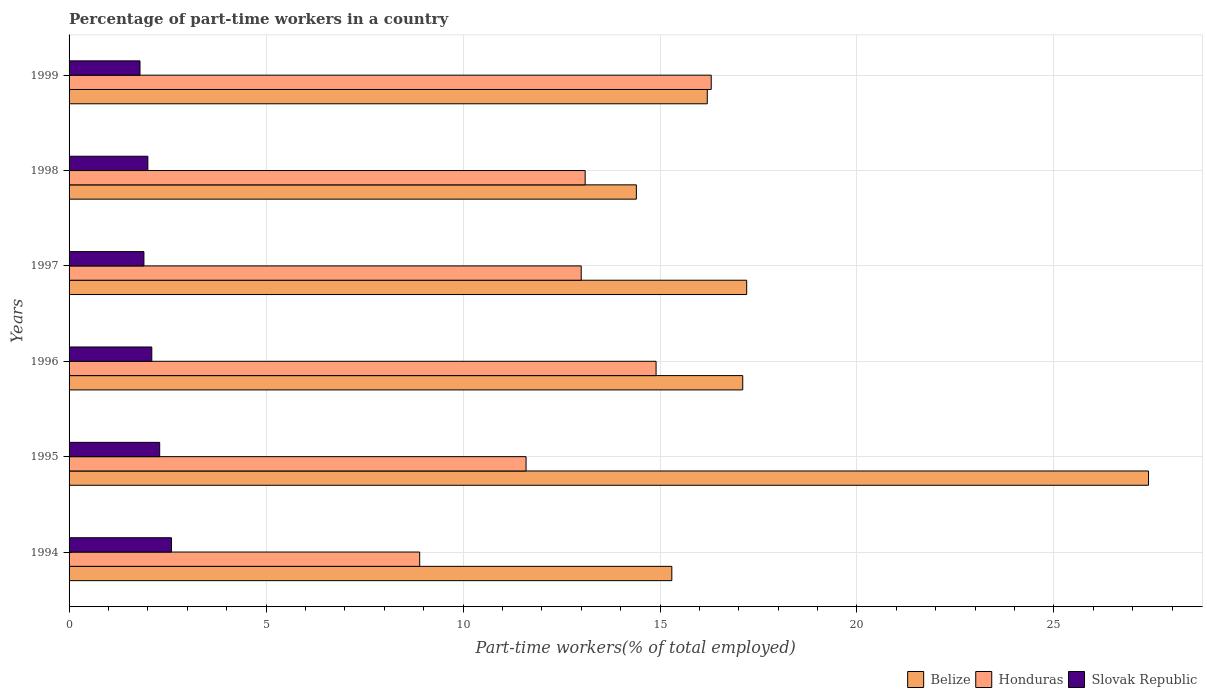Are the number of bars per tick equal to the number of legend labels?
Ensure brevity in your answer.  Yes. Are the number of bars on each tick of the Y-axis equal?
Make the answer very short. Yes. How many bars are there on the 4th tick from the bottom?
Make the answer very short. 3. What is the percentage of part-time workers in Slovak Republic in 1994?
Offer a terse response. 2.6. Across all years, what is the maximum percentage of part-time workers in Slovak Republic?
Ensure brevity in your answer.  2.6. Across all years, what is the minimum percentage of part-time workers in Belize?
Your answer should be compact. 14.4. What is the total percentage of part-time workers in Honduras in the graph?
Provide a succinct answer. 77.8. What is the difference between the percentage of part-time workers in Honduras in 1994 and that in 1997?
Your answer should be compact. -4.1. What is the difference between the percentage of part-time workers in Honduras in 1994 and the percentage of part-time workers in Slovak Republic in 1995?
Provide a short and direct response. 6.6. What is the average percentage of part-time workers in Slovak Republic per year?
Give a very brief answer. 2.12. In the year 1999, what is the difference between the percentage of part-time workers in Honduras and percentage of part-time workers in Belize?
Offer a terse response. 0.1. What is the ratio of the percentage of part-time workers in Honduras in 1996 to that in 1999?
Keep it short and to the point. 0.91. Is the difference between the percentage of part-time workers in Honduras in 1994 and 1997 greater than the difference between the percentage of part-time workers in Belize in 1994 and 1997?
Offer a very short reply. No. What is the difference between the highest and the second highest percentage of part-time workers in Belize?
Keep it short and to the point. 10.2. What is the difference between the highest and the lowest percentage of part-time workers in Slovak Republic?
Ensure brevity in your answer.  0.8. In how many years, is the percentage of part-time workers in Honduras greater than the average percentage of part-time workers in Honduras taken over all years?
Ensure brevity in your answer.  4. Is the sum of the percentage of part-time workers in Slovak Republic in 1995 and 1999 greater than the maximum percentage of part-time workers in Honduras across all years?
Offer a terse response. No. What does the 1st bar from the top in 1996 represents?
Offer a very short reply. Slovak Republic. What does the 1st bar from the bottom in 1994 represents?
Provide a short and direct response. Belize. Is it the case that in every year, the sum of the percentage of part-time workers in Belize and percentage of part-time workers in Honduras is greater than the percentage of part-time workers in Slovak Republic?
Provide a succinct answer. Yes. How many bars are there?
Your answer should be compact. 18. Are all the bars in the graph horizontal?
Ensure brevity in your answer.  Yes. Does the graph contain any zero values?
Ensure brevity in your answer.  No. Does the graph contain grids?
Your answer should be very brief. Yes. What is the title of the graph?
Provide a succinct answer. Percentage of part-time workers in a country. What is the label or title of the X-axis?
Make the answer very short. Part-time workers(% of total employed). What is the label or title of the Y-axis?
Keep it short and to the point. Years. What is the Part-time workers(% of total employed) of Belize in 1994?
Offer a very short reply. 15.3. What is the Part-time workers(% of total employed) in Honduras in 1994?
Keep it short and to the point. 8.9. What is the Part-time workers(% of total employed) in Slovak Republic in 1994?
Provide a short and direct response. 2.6. What is the Part-time workers(% of total employed) in Belize in 1995?
Give a very brief answer. 27.4. What is the Part-time workers(% of total employed) of Honduras in 1995?
Your response must be concise. 11.6. What is the Part-time workers(% of total employed) in Slovak Republic in 1995?
Provide a short and direct response. 2.3. What is the Part-time workers(% of total employed) of Belize in 1996?
Offer a very short reply. 17.1. What is the Part-time workers(% of total employed) of Honduras in 1996?
Give a very brief answer. 14.9. What is the Part-time workers(% of total employed) in Slovak Republic in 1996?
Offer a very short reply. 2.1. What is the Part-time workers(% of total employed) in Belize in 1997?
Your answer should be compact. 17.2. What is the Part-time workers(% of total employed) in Honduras in 1997?
Provide a short and direct response. 13. What is the Part-time workers(% of total employed) of Slovak Republic in 1997?
Provide a short and direct response. 1.9. What is the Part-time workers(% of total employed) in Belize in 1998?
Give a very brief answer. 14.4. What is the Part-time workers(% of total employed) of Honduras in 1998?
Your answer should be very brief. 13.1. What is the Part-time workers(% of total employed) of Slovak Republic in 1998?
Make the answer very short. 2. What is the Part-time workers(% of total employed) in Belize in 1999?
Give a very brief answer. 16.2. What is the Part-time workers(% of total employed) in Honduras in 1999?
Make the answer very short. 16.3. What is the Part-time workers(% of total employed) of Slovak Republic in 1999?
Provide a succinct answer. 1.8. Across all years, what is the maximum Part-time workers(% of total employed) in Belize?
Your answer should be compact. 27.4. Across all years, what is the maximum Part-time workers(% of total employed) of Honduras?
Keep it short and to the point. 16.3. Across all years, what is the maximum Part-time workers(% of total employed) in Slovak Republic?
Keep it short and to the point. 2.6. Across all years, what is the minimum Part-time workers(% of total employed) in Belize?
Your answer should be very brief. 14.4. Across all years, what is the minimum Part-time workers(% of total employed) of Honduras?
Your answer should be very brief. 8.9. Across all years, what is the minimum Part-time workers(% of total employed) in Slovak Republic?
Offer a terse response. 1.8. What is the total Part-time workers(% of total employed) in Belize in the graph?
Provide a succinct answer. 107.6. What is the total Part-time workers(% of total employed) of Honduras in the graph?
Provide a succinct answer. 77.8. What is the total Part-time workers(% of total employed) of Slovak Republic in the graph?
Your answer should be compact. 12.7. What is the difference between the Part-time workers(% of total employed) of Belize in 1994 and that in 1995?
Offer a terse response. -12.1. What is the difference between the Part-time workers(% of total employed) in Honduras in 1994 and that in 1995?
Offer a very short reply. -2.7. What is the difference between the Part-time workers(% of total employed) of Slovak Republic in 1994 and that in 1995?
Your response must be concise. 0.3. What is the difference between the Part-time workers(% of total employed) in Belize in 1994 and that in 1996?
Your answer should be very brief. -1.8. What is the difference between the Part-time workers(% of total employed) in Honduras in 1994 and that in 1996?
Your answer should be compact. -6. What is the difference between the Part-time workers(% of total employed) in Belize in 1994 and that in 1997?
Ensure brevity in your answer.  -1.9. What is the difference between the Part-time workers(% of total employed) in Honduras in 1994 and that in 1997?
Make the answer very short. -4.1. What is the difference between the Part-time workers(% of total employed) in Slovak Republic in 1994 and that in 1997?
Ensure brevity in your answer.  0.7. What is the difference between the Part-time workers(% of total employed) of Honduras in 1994 and that in 1998?
Ensure brevity in your answer.  -4.2. What is the difference between the Part-time workers(% of total employed) in Slovak Republic in 1994 and that in 1998?
Keep it short and to the point. 0.6. What is the difference between the Part-time workers(% of total employed) in Belize in 1994 and that in 1999?
Provide a succinct answer. -0.9. What is the difference between the Part-time workers(% of total employed) of Belize in 1995 and that in 1996?
Offer a terse response. 10.3. What is the difference between the Part-time workers(% of total employed) in Slovak Republic in 1995 and that in 1997?
Ensure brevity in your answer.  0.4. What is the difference between the Part-time workers(% of total employed) of Belize in 1995 and that in 1998?
Your response must be concise. 13. What is the difference between the Part-time workers(% of total employed) in Slovak Republic in 1995 and that in 1998?
Offer a terse response. 0.3. What is the difference between the Part-time workers(% of total employed) of Slovak Republic in 1995 and that in 1999?
Offer a terse response. 0.5. What is the difference between the Part-time workers(% of total employed) in Belize in 1996 and that in 1997?
Provide a short and direct response. -0.1. What is the difference between the Part-time workers(% of total employed) in Belize in 1996 and that in 1998?
Ensure brevity in your answer.  2.7. What is the difference between the Part-time workers(% of total employed) of Slovak Republic in 1996 and that in 1998?
Your answer should be compact. 0.1. What is the difference between the Part-time workers(% of total employed) in Honduras in 1996 and that in 1999?
Ensure brevity in your answer.  -1.4. What is the difference between the Part-time workers(% of total employed) of Slovak Republic in 1996 and that in 1999?
Your answer should be very brief. 0.3. What is the difference between the Part-time workers(% of total employed) of Belize in 1997 and that in 1998?
Your answer should be compact. 2.8. What is the difference between the Part-time workers(% of total employed) of Honduras in 1997 and that in 1998?
Give a very brief answer. -0.1. What is the difference between the Part-time workers(% of total employed) of Slovak Republic in 1997 and that in 1998?
Offer a terse response. -0.1. What is the difference between the Part-time workers(% of total employed) of Belize in 1997 and that in 1999?
Your response must be concise. 1. What is the difference between the Part-time workers(% of total employed) of Slovak Republic in 1997 and that in 1999?
Offer a very short reply. 0.1. What is the difference between the Part-time workers(% of total employed) of Belize in 1998 and that in 1999?
Offer a terse response. -1.8. What is the difference between the Part-time workers(% of total employed) of Honduras in 1998 and that in 1999?
Give a very brief answer. -3.2. What is the difference between the Part-time workers(% of total employed) of Honduras in 1994 and the Part-time workers(% of total employed) of Slovak Republic in 1996?
Ensure brevity in your answer.  6.8. What is the difference between the Part-time workers(% of total employed) in Belize in 1994 and the Part-time workers(% of total employed) in Slovak Republic in 1997?
Provide a short and direct response. 13.4. What is the difference between the Part-time workers(% of total employed) in Belize in 1994 and the Part-time workers(% of total employed) in Slovak Republic in 1998?
Keep it short and to the point. 13.3. What is the difference between the Part-time workers(% of total employed) in Belize in 1994 and the Part-time workers(% of total employed) in Honduras in 1999?
Your answer should be compact. -1. What is the difference between the Part-time workers(% of total employed) of Belize in 1994 and the Part-time workers(% of total employed) of Slovak Republic in 1999?
Ensure brevity in your answer.  13.5. What is the difference between the Part-time workers(% of total employed) in Honduras in 1994 and the Part-time workers(% of total employed) in Slovak Republic in 1999?
Make the answer very short. 7.1. What is the difference between the Part-time workers(% of total employed) of Belize in 1995 and the Part-time workers(% of total employed) of Honduras in 1996?
Offer a very short reply. 12.5. What is the difference between the Part-time workers(% of total employed) of Belize in 1995 and the Part-time workers(% of total employed) of Slovak Republic in 1996?
Offer a very short reply. 25.3. What is the difference between the Part-time workers(% of total employed) in Honduras in 1995 and the Part-time workers(% of total employed) in Slovak Republic in 1996?
Your answer should be compact. 9.5. What is the difference between the Part-time workers(% of total employed) in Belize in 1995 and the Part-time workers(% of total employed) in Slovak Republic in 1997?
Provide a short and direct response. 25.5. What is the difference between the Part-time workers(% of total employed) of Honduras in 1995 and the Part-time workers(% of total employed) of Slovak Republic in 1997?
Offer a terse response. 9.7. What is the difference between the Part-time workers(% of total employed) in Belize in 1995 and the Part-time workers(% of total employed) in Honduras in 1998?
Offer a very short reply. 14.3. What is the difference between the Part-time workers(% of total employed) of Belize in 1995 and the Part-time workers(% of total employed) of Slovak Republic in 1998?
Your response must be concise. 25.4. What is the difference between the Part-time workers(% of total employed) of Honduras in 1995 and the Part-time workers(% of total employed) of Slovak Republic in 1998?
Ensure brevity in your answer.  9.6. What is the difference between the Part-time workers(% of total employed) in Belize in 1995 and the Part-time workers(% of total employed) in Honduras in 1999?
Ensure brevity in your answer.  11.1. What is the difference between the Part-time workers(% of total employed) of Belize in 1995 and the Part-time workers(% of total employed) of Slovak Republic in 1999?
Provide a succinct answer. 25.6. What is the difference between the Part-time workers(% of total employed) of Honduras in 1995 and the Part-time workers(% of total employed) of Slovak Republic in 1999?
Make the answer very short. 9.8. What is the difference between the Part-time workers(% of total employed) in Belize in 1996 and the Part-time workers(% of total employed) in Honduras in 1998?
Provide a short and direct response. 4. What is the difference between the Part-time workers(% of total employed) of Honduras in 1996 and the Part-time workers(% of total employed) of Slovak Republic in 1998?
Give a very brief answer. 12.9. What is the difference between the Part-time workers(% of total employed) of Honduras in 1996 and the Part-time workers(% of total employed) of Slovak Republic in 1999?
Give a very brief answer. 13.1. What is the difference between the Part-time workers(% of total employed) in Belize in 1997 and the Part-time workers(% of total employed) in Honduras in 1998?
Your answer should be very brief. 4.1. What is the difference between the Part-time workers(% of total employed) in Belize in 1997 and the Part-time workers(% of total employed) in Slovak Republic in 1998?
Make the answer very short. 15.2. What is the difference between the Part-time workers(% of total employed) in Belize in 1997 and the Part-time workers(% of total employed) in Honduras in 1999?
Your response must be concise. 0.9. What is the difference between the Part-time workers(% of total employed) of Belize in 1997 and the Part-time workers(% of total employed) of Slovak Republic in 1999?
Your answer should be very brief. 15.4. What is the difference between the Part-time workers(% of total employed) in Honduras in 1998 and the Part-time workers(% of total employed) in Slovak Republic in 1999?
Your response must be concise. 11.3. What is the average Part-time workers(% of total employed) in Belize per year?
Offer a terse response. 17.93. What is the average Part-time workers(% of total employed) in Honduras per year?
Provide a short and direct response. 12.97. What is the average Part-time workers(% of total employed) in Slovak Republic per year?
Provide a succinct answer. 2.12. In the year 1994, what is the difference between the Part-time workers(% of total employed) of Belize and Part-time workers(% of total employed) of Honduras?
Offer a very short reply. 6.4. In the year 1994, what is the difference between the Part-time workers(% of total employed) in Belize and Part-time workers(% of total employed) in Slovak Republic?
Your answer should be compact. 12.7. In the year 1995, what is the difference between the Part-time workers(% of total employed) of Belize and Part-time workers(% of total employed) of Slovak Republic?
Provide a short and direct response. 25.1. In the year 1997, what is the difference between the Part-time workers(% of total employed) in Honduras and Part-time workers(% of total employed) in Slovak Republic?
Keep it short and to the point. 11.1. In the year 1998, what is the difference between the Part-time workers(% of total employed) of Belize and Part-time workers(% of total employed) of Slovak Republic?
Your response must be concise. 12.4. In the year 1998, what is the difference between the Part-time workers(% of total employed) in Honduras and Part-time workers(% of total employed) in Slovak Republic?
Provide a succinct answer. 11.1. In the year 1999, what is the difference between the Part-time workers(% of total employed) of Belize and Part-time workers(% of total employed) of Honduras?
Give a very brief answer. -0.1. In the year 1999, what is the difference between the Part-time workers(% of total employed) of Belize and Part-time workers(% of total employed) of Slovak Republic?
Provide a succinct answer. 14.4. In the year 1999, what is the difference between the Part-time workers(% of total employed) of Honduras and Part-time workers(% of total employed) of Slovak Republic?
Your answer should be very brief. 14.5. What is the ratio of the Part-time workers(% of total employed) of Belize in 1994 to that in 1995?
Your response must be concise. 0.56. What is the ratio of the Part-time workers(% of total employed) of Honduras in 1994 to that in 1995?
Your answer should be very brief. 0.77. What is the ratio of the Part-time workers(% of total employed) of Slovak Republic in 1994 to that in 1995?
Make the answer very short. 1.13. What is the ratio of the Part-time workers(% of total employed) in Belize in 1994 to that in 1996?
Your answer should be very brief. 0.89. What is the ratio of the Part-time workers(% of total employed) in Honduras in 1994 to that in 1996?
Provide a short and direct response. 0.6. What is the ratio of the Part-time workers(% of total employed) of Slovak Republic in 1994 to that in 1996?
Ensure brevity in your answer.  1.24. What is the ratio of the Part-time workers(% of total employed) of Belize in 1994 to that in 1997?
Give a very brief answer. 0.89. What is the ratio of the Part-time workers(% of total employed) in Honduras in 1994 to that in 1997?
Keep it short and to the point. 0.68. What is the ratio of the Part-time workers(% of total employed) in Slovak Republic in 1994 to that in 1997?
Offer a terse response. 1.37. What is the ratio of the Part-time workers(% of total employed) of Belize in 1994 to that in 1998?
Your response must be concise. 1.06. What is the ratio of the Part-time workers(% of total employed) in Honduras in 1994 to that in 1998?
Give a very brief answer. 0.68. What is the ratio of the Part-time workers(% of total employed) in Honduras in 1994 to that in 1999?
Ensure brevity in your answer.  0.55. What is the ratio of the Part-time workers(% of total employed) of Slovak Republic in 1994 to that in 1999?
Ensure brevity in your answer.  1.44. What is the ratio of the Part-time workers(% of total employed) in Belize in 1995 to that in 1996?
Ensure brevity in your answer.  1.6. What is the ratio of the Part-time workers(% of total employed) of Honduras in 1995 to that in 1996?
Your answer should be very brief. 0.78. What is the ratio of the Part-time workers(% of total employed) in Slovak Republic in 1995 to that in 1996?
Keep it short and to the point. 1.1. What is the ratio of the Part-time workers(% of total employed) of Belize in 1995 to that in 1997?
Provide a succinct answer. 1.59. What is the ratio of the Part-time workers(% of total employed) of Honduras in 1995 to that in 1997?
Ensure brevity in your answer.  0.89. What is the ratio of the Part-time workers(% of total employed) of Slovak Republic in 1995 to that in 1997?
Your response must be concise. 1.21. What is the ratio of the Part-time workers(% of total employed) in Belize in 1995 to that in 1998?
Give a very brief answer. 1.9. What is the ratio of the Part-time workers(% of total employed) of Honduras in 1995 to that in 1998?
Provide a short and direct response. 0.89. What is the ratio of the Part-time workers(% of total employed) in Slovak Republic in 1995 to that in 1998?
Your answer should be compact. 1.15. What is the ratio of the Part-time workers(% of total employed) of Belize in 1995 to that in 1999?
Give a very brief answer. 1.69. What is the ratio of the Part-time workers(% of total employed) of Honduras in 1995 to that in 1999?
Your response must be concise. 0.71. What is the ratio of the Part-time workers(% of total employed) in Slovak Republic in 1995 to that in 1999?
Keep it short and to the point. 1.28. What is the ratio of the Part-time workers(% of total employed) of Honduras in 1996 to that in 1997?
Provide a short and direct response. 1.15. What is the ratio of the Part-time workers(% of total employed) in Slovak Republic in 1996 to that in 1997?
Keep it short and to the point. 1.11. What is the ratio of the Part-time workers(% of total employed) of Belize in 1996 to that in 1998?
Keep it short and to the point. 1.19. What is the ratio of the Part-time workers(% of total employed) of Honduras in 1996 to that in 1998?
Give a very brief answer. 1.14. What is the ratio of the Part-time workers(% of total employed) in Belize in 1996 to that in 1999?
Your answer should be compact. 1.06. What is the ratio of the Part-time workers(% of total employed) in Honduras in 1996 to that in 1999?
Offer a very short reply. 0.91. What is the ratio of the Part-time workers(% of total employed) of Belize in 1997 to that in 1998?
Keep it short and to the point. 1.19. What is the ratio of the Part-time workers(% of total employed) in Slovak Republic in 1997 to that in 1998?
Your answer should be compact. 0.95. What is the ratio of the Part-time workers(% of total employed) of Belize in 1997 to that in 1999?
Offer a very short reply. 1.06. What is the ratio of the Part-time workers(% of total employed) of Honduras in 1997 to that in 1999?
Your response must be concise. 0.8. What is the ratio of the Part-time workers(% of total employed) of Slovak Republic in 1997 to that in 1999?
Offer a terse response. 1.06. What is the ratio of the Part-time workers(% of total employed) of Honduras in 1998 to that in 1999?
Provide a succinct answer. 0.8. What is the difference between the highest and the second highest Part-time workers(% of total employed) in Belize?
Offer a very short reply. 10.2. What is the difference between the highest and the second highest Part-time workers(% of total employed) of Honduras?
Your answer should be very brief. 1.4. What is the difference between the highest and the second highest Part-time workers(% of total employed) in Slovak Republic?
Keep it short and to the point. 0.3. What is the difference between the highest and the lowest Part-time workers(% of total employed) of Belize?
Your response must be concise. 13. What is the difference between the highest and the lowest Part-time workers(% of total employed) of Honduras?
Your response must be concise. 7.4. What is the difference between the highest and the lowest Part-time workers(% of total employed) in Slovak Republic?
Your response must be concise. 0.8. 